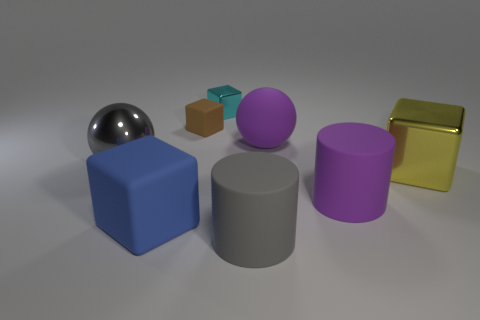Subtract all brown cubes. How many cubes are left? 3 Add 2 gray cylinders. How many objects exist? 10 Subtract all cylinders. How many objects are left? 6 Subtract all purple balls. How many balls are left? 1 Subtract 2 cylinders. How many cylinders are left? 0 Subtract all blue cubes. Subtract all purple balls. How many cubes are left? 3 Subtract all blue cylinders. How many purple cubes are left? 0 Subtract all small yellow shiny things. Subtract all tiny shiny objects. How many objects are left? 7 Add 3 cyan cubes. How many cyan cubes are left? 4 Add 4 big purple balls. How many big purple balls exist? 5 